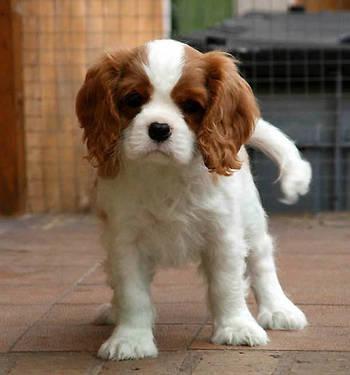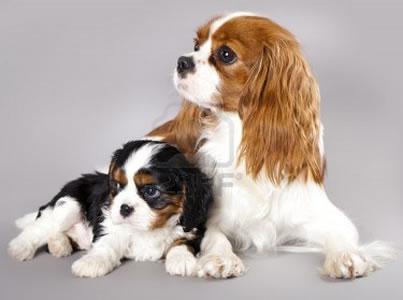The first image is the image on the left, the second image is the image on the right. For the images displayed, is the sentence "There are a total of three animals." factually correct? Answer yes or no. Yes. The first image is the image on the left, the second image is the image on the right. Given the left and right images, does the statement "There are at most two dogs." hold true? Answer yes or no. No. 